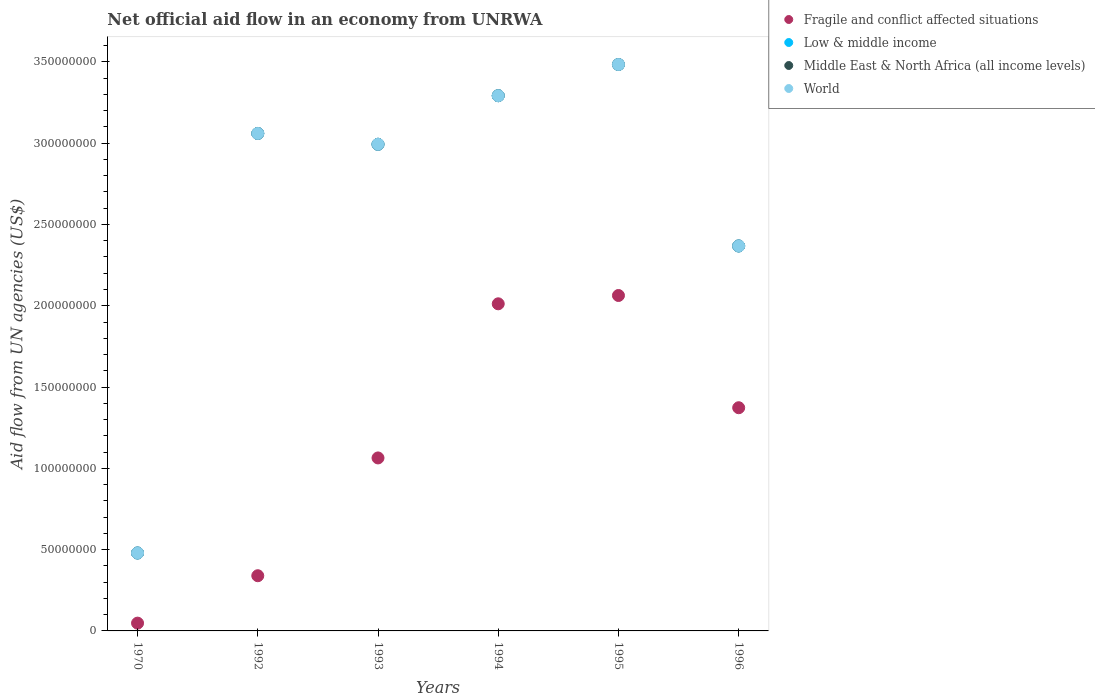What is the net official aid flow in Middle East & North Africa (all income levels) in 1993?
Provide a succinct answer. 2.99e+08. Across all years, what is the maximum net official aid flow in Low & middle income?
Your response must be concise. 3.48e+08. Across all years, what is the minimum net official aid flow in Low & middle income?
Offer a very short reply. 4.79e+07. In which year was the net official aid flow in Middle East & North Africa (all income levels) maximum?
Make the answer very short. 1995. In which year was the net official aid flow in World minimum?
Give a very brief answer. 1970. What is the total net official aid flow in Fragile and conflict affected situations in the graph?
Make the answer very short. 6.90e+08. What is the difference between the net official aid flow in Low & middle income in 1993 and that in 1994?
Provide a succinct answer. -2.99e+07. What is the difference between the net official aid flow in Low & middle income in 1970 and the net official aid flow in World in 1996?
Provide a succinct answer. -1.89e+08. What is the average net official aid flow in Fragile and conflict affected situations per year?
Keep it short and to the point. 1.15e+08. In the year 1993, what is the difference between the net official aid flow in Fragile and conflict affected situations and net official aid flow in Middle East & North Africa (all income levels)?
Your answer should be compact. -1.93e+08. What is the ratio of the net official aid flow in Fragile and conflict affected situations in 1970 to that in 1996?
Ensure brevity in your answer.  0.03. Is the difference between the net official aid flow in Fragile and conflict affected situations in 1970 and 1996 greater than the difference between the net official aid flow in Middle East & North Africa (all income levels) in 1970 and 1996?
Offer a terse response. Yes. What is the difference between the highest and the second highest net official aid flow in Low & middle income?
Keep it short and to the point. 1.92e+07. What is the difference between the highest and the lowest net official aid flow in Low & middle income?
Provide a succinct answer. 3.00e+08. Is the sum of the net official aid flow in Middle East & North Africa (all income levels) in 1970 and 1994 greater than the maximum net official aid flow in Fragile and conflict affected situations across all years?
Provide a succinct answer. Yes. Is it the case that in every year, the sum of the net official aid flow in Low & middle income and net official aid flow in Fragile and conflict affected situations  is greater than the sum of net official aid flow in World and net official aid flow in Middle East & North Africa (all income levels)?
Provide a succinct answer. No. Is it the case that in every year, the sum of the net official aid flow in Fragile and conflict affected situations and net official aid flow in Low & middle income  is greater than the net official aid flow in Middle East & North Africa (all income levels)?
Give a very brief answer. Yes. Is the net official aid flow in World strictly greater than the net official aid flow in Fragile and conflict affected situations over the years?
Provide a short and direct response. Yes. Is the net official aid flow in World strictly less than the net official aid flow in Low & middle income over the years?
Offer a terse response. No. How many years are there in the graph?
Keep it short and to the point. 6. What is the difference between two consecutive major ticks on the Y-axis?
Give a very brief answer. 5.00e+07. Does the graph contain any zero values?
Keep it short and to the point. No. How many legend labels are there?
Keep it short and to the point. 4. What is the title of the graph?
Offer a very short reply. Net official aid flow in an economy from UNRWA. What is the label or title of the X-axis?
Keep it short and to the point. Years. What is the label or title of the Y-axis?
Offer a very short reply. Aid flow from UN agencies (US$). What is the Aid flow from UN agencies (US$) in Fragile and conflict affected situations in 1970?
Provide a short and direct response. 4.79e+06. What is the Aid flow from UN agencies (US$) in Low & middle income in 1970?
Your answer should be compact. 4.79e+07. What is the Aid flow from UN agencies (US$) of Middle East & North Africa (all income levels) in 1970?
Give a very brief answer. 4.79e+07. What is the Aid flow from UN agencies (US$) in World in 1970?
Make the answer very short. 4.79e+07. What is the Aid flow from UN agencies (US$) in Fragile and conflict affected situations in 1992?
Provide a succinct answer. 3.40e+07. What is the Aid flow from UN agencies (US$) of Low & middle income in 1992?
Make the answer very short. 3.06e+08. What is the Aid flow from UN agencies (US$) of Middle East & North Africa (all income levels) in 1992?
Provide a short and direct response. 3.06e+08. What is the Aid flow from UN agencies (US$) in World in 1992?
Make the answer very short. 3.06e+08. What is the Aid flow from UN agencies (US$) of Fragile and conflict affected situations in 1993?
Provide a short and direct response. 1.06e+08. What is the Aid flow from UN agencies (US$) in Low & middle income in 1993?
Offer a terse response. 2.99e+08. What is the Aid flow from UN agencies (US$) in Middle East & North Africa (all income levels) in 1993?
Your answer should be compact. 2.99e+08. What is the Aid flow from UN agencies (US$) in World in 1993?
Keep it short and to the point. 2.99e+08. What is the Aid flow from UN agencies (US$) of Fragile and conflict affected situations in 1994?
Make the answer very short. 2.01e+08. What is the Aid flow from UN agencies (US$) in Low & middle income in 1994?
Ensure brevity in your answer.  3.29e+08. What is the Aid flow from UN agencies (US$) of Middle East & North Africa (all income levels) in 1994?
Keep it short and to the point. 3.29e+08. What is the Aid flow from UN agencies (US$) of World in 1994?
Offer a terse response. 3.29e+08. What is the Aid flow from UN agencies (US$) of Fragile and conflict affected situations in 1995?
Provide a succinct answer. 2.06e+08. What is the Aid flow from UN agencies (US$) of Low & middle income in 1995?
Give a very brief answer. 3.48e+08. What is the Aid flow from UN agencies (US$) of Middle East & North Africa (all income levels) in 1995?
Ensure brevity in your answer.  3.48e+08. What is the Aid flow from UN agencies (US$) in World in 1995?
Make the answer very short. 3.48e+08. What is the Aid flow from UN agencies (US$) in Fragile and conflict affected situations in 1996?
Keep it short and to the point. 1.37e+08. What is the Aid flow from UN agencies (US$) of Low & middle income in 1996?
Ensure brevity in your answer.  2.37e+08. What is the Aid flow from UN agencies (US$) of Middle East & North Africa (all income levels) in 1996?
Provide a succinct answer. 2.37e+08. What is the Aid flow from UN agencies (US$) of World in 1996?
Offer a very short reply. 2.37e+08. Across all years, what is the maximum Aid flow from UN agencies (US$) in Fragile and conflict affected situations?
Your response must be concise. 2.06e+08. Across all years, what is the maximum Aid flow from UN agencies (US$) of Low & middle income?
Your answer should be very brief. 3.48e+08. Across all years, what is the maximum Aid flow from UN agencies (US$) in Middle East & North Africa (all income levels)?
Your response must be concise. 3.48e+08. Across all years, what is the maximum Aid flow from UN agencies (US$) of World?
Provide a succinct answer. 3.48e+08. Across all years, what is the minimum Aid flow from UN agencies (US$) in Fragile and conflict affected situations?
Provide a short and direct response. 4.79e+06. Across all years, what is the minimum Aid flow from UN agencies (US$) in Low & middle income?
Make the answer very short. 4.79e+07. Across all years, what is the minimum Aid flow from UN agencies (US$) in Middle East & North Africa (all income levels)?
Offer a very short reply. 4.79e+07. Across all years, what is the minimum Aid flow from UN agencies (US$) in World?
Your answer should be compact. 4.79e+07. What is the total Aid flow from UN agencies (US$) of Fragile and conflict affected situations in the graph?
Provide a short and direct response. 6.90e+08. What is the total Aid flow from UN agencies (US$) of Low & middle income in the graph?
Offer a very short reply. 1.57e+09. What is the total Aid flow from UN agencies (US$) of Middle East & North Africa (all income levels) in the graph?
Give a very brief answer. 1.57e+09. What is the total Aid flow from UN agencies (US$) of World in the graph?
Offer a terse response. 1.57e+09. What is the difference between the Aid flow from UN agencies (US$) in Fragile and conflict affected situations in 1970 and that in 1992?
Your answer should be very brief. -2.92e+07. What is the difference between the Aid flow from UN agencies (US$) in Low & middle income in 1970 and that in 1992?
Make the answer very short. -2.58e+08. What is the difference between the Aid flow from UN agencies (US$) in Middle East & North Africa (all income levels) in 1970 and that in 1992?
Provide a succinct answer. -2.58e+08. What is the difference between the Aid flow from UN agencies (US$) in World in 1970 and that in 1992?
Give a very brief answer. -2.58e+08. What is the difference between the Aid flow from UN agencies (US$) in Fragile and conflict affected situations in 1970 and that in 1993?
Your response must be concise. -1.02e+08. What is the difference between the Aid flow from UN agencies (US$) of Low & middle income in 1970 and that in 1993?
Ensure brevity in your answer.  -2.51e+08. What is the difference between the Aid flow from UN agencies (US$) of Middle East & North Africa (all income levels) in 1970 and that in 1993?
Ensure brevity in your answer.  -2.51e+08. What is the difference between the Aid flow from UN agencies (US$) in World in 1970 and that in 1993?
Make the answer very short. -2.51e+08. What is the difference between the Aid flow from UN agencies (US$) of Fragile and conflict affected situations in 1970 and that in 1994?
Give a very brief answer. -1.96e+08. What is the difference between the Aid flow from UN agencies (US$) in Low & middle income in 1970 and that in 1994?
Keep it short and to the point. -2.81e+08. What is the difference between the Aid flow from UN agencies (US$) in Middle East & North Africa (all income levels) in 1970 and that in 1994?
Ensure brevity in your answer.  -2.81e+08. What is the difference between the Aid flow from UN agencies (US$) in World in 1970 and that in 1994?
Give a very brief answer. -2.81e+08. What is the difference between the Aid flow from UN agencies (US$) in Fragile and conflict affected situations in 1970 and that in 1995?
Provide a short and direct response. -2.02e+08. What is the difference between the Aid flow from UN agencies (US$) of Low & middle income in 1970 and that in 1995?
Provide a short and direct response. -3.00e+08. What is the difference between the Aid flow from UN agencies (US$) in Middle East & North Africa (all income levels) in 1970 and that in 1995?
Give a very brief answer. -3.00e+08. What is the difference between the Aid flow from UN agencies (US$) in World in 1970 and that in 1995?
Give a very brief answer. -3.00e+08. What is the difference between the Aid flow from UN agencies (US$) of Fragile and conflict affected situations in 1970 and that in 1996?
Keep it short and to the point. -1.32e+08. What is the difference between the Aid flow from UN agencies (US$) in Low & middle income in 1970 and that in 1996?
Offer a very short reply. -1.89e+08. What is the difference between the Aid flow from UN agencies (US$) of Middle East & North Africa (all income levels) in 1970 and that in 1996?
Your answer should be very brief. -1.89e+08. What is the difference between the Aid flow from UN agencies (US$) of World in 1970 and that in 1996?
Your answer should be compact. -1.89e+08. What is the difference between the Aid flow from UN agencies (US$) in Fragile and conflict affected situations in 1992 and that in 1993?
Give a very brief answer. -7.24e+07. What is the difference between the Aid flow from UN agencies (US$) of Low & middle income in 1992 and that in 1993?
Your answer should be compact. 6.65e+06. What is the difference between the Aid flow from UN agencies (US$) of Middle East & North Africa (all income levels) in 1992 and that in 1993?
Offer a terse response. 6.65e+06. What is the difference between the Aid flow from UN agencies (US$) of World in 1992 and that in 1993?
Your answer should be very brief. 6.65e+06. What is the difference between the Aid flow from UN agencies (US$) of Fragile and conflict affected situations in 1992 and that in 1994?
Provide a succinct answer. -1.67e+08. What is the difference between the Aid flow from UN agencies (US$) of Low & middle income in 1992 and that in 1994?
Your response must be concise. -2.32e+07. What is the difference between the Aid flow from UN agencies (US$) of Middle East & North Africa (all income levels) in 1992 and that in 1994?
Your response must be concise. -2.32e+07. What is the difference between the Aid flow from UN agencies (US$) of World in 1992 and that in 1994?
Offer a very short reply. -2.32e+07. What is the difference between the Aid flow from UN agencies (US$) of Fragile and conflict affected situations in 1992 and that in 1995?
Keep it short and to the point. -1.72e+08. What is the difference between the Aid flow from UN agencies (US$) of Low & middle income in 1992 and that in 1995?
Offer a terse response. -4.24e+07. What is the difference between the Aid flow from UN agencies (US$) in Middle East & North Africa (all income levels) in 1992 and that in 1995?
Your answer should be compact. -4.24e+07. What is the difference between the Aid flow from UN agencies (US$) of World in 1992 and that in 1995?
Make the answer very short. -4.24e+07. What is the difference between the Aid flow from UN agencies (US$) of Fragile and conflict affected situations in 1992 and that in 1996?
Offer a very short reply. -1.03e+08. What is the difference between the Aid flow from UN agencies (US$) of Low & middle income in 1992 and that in 1996?
Provide a short and direct response. 6.92e+07. What is the difference between the Aid flow from UN agencies (US$) in Middle East & North Africa (all income levels) in 1992 and that in 1996?
Provide a succinct answer. 6.92e+07. What is the difference between the Aid flow from UN agencies (US$) of World in 1992 and that in 1996?
Your answer should be compact. 6.92e+07. What is the difference between the Aid flow from UN agencies (US$) of Fragile and conflict affected situations in 1993 and that in 1994?
Offer a very short reply. -9.48e+07. What is the difference between the Aid flow from UN agencies (US$) of Low & middle income in 1993 and that in 1994?
Your answer should be very brief. -2.99e+07. What is the difference between the Aid flow from UN agencies (US$) in Middle East & North Africa (all income levels) in 1993 and that in 1994?
Your response must be concise. -2.99e+07. What is the difference between the Aid flow from UN agencies (US$) of World in 1993 and that in 1994?
Make the answer very short. -2.99e+07. What is the difference between the Aid flow from UN agencies (US$) of Fragile and conflict affected situations in 1993 and that in 1995?
Provide a short and direct response. -9.99e+07. What is the difference between the Aid flow from UN agencies (US$) in Low & middle income in 1993 and that in 1995?
Offer a very short reply. -4.91e+07. What is the difference between the Aid flow from UN agencies (US$) of Middle East & North Africa (all income levels) in 1993 and that in 1995?
Offer a very short reply. -4.91e+07. What is the difference between the Aid flow from UN agencies (US$) of World in 1993 and that in 1995?
Provide a succinct answer. -4.91e+07. What is the difference between the Aid flow from UN agencies (US$) of Fragile and conflict affected situations in 1993 and that in 1996?
Offer a very short reply. -3.09e+07. What is the difference between the Aid flow from UN agencies (US$) of Low & middle income in 1993 and that in 1996?
Your answer should be compact. 6.26e+07. What is the difference between the Aid flow from UN agencies (US$) of Middle East & North Africa (all income levels) in 1993 and that in 1996?
Make the answer very short. 6.26e+07. What is the difference between the Aid flow from UN agencies (US$) of World in 1993 and that in 1996?
Provide a short and direct response. 6.26e+07. What is the difference between the Aid flow from UN agencies (US$) in Fragile and conflict affected situations in 1994 and that in 1995?
Provide a succinct answer. -5.11e+06. What is the difference between the Aid flow from UN agencies (US$) of Low & middle income in 1994 and that in 1995?
Offer a terse response. -1.92e+07. What is the difference between the Aid flow from UN agencies (US$) of Middle East & North Africa (all income levels) in 1994 and that in 1995?
Offer a terse response. -1.92e+07. What is the difference between the Aid flow from UN agencies (US$) in World in 1994 and that in 1995?
Offer a very short reply. -1.92e+07. What is the difference between the Aid flow from UN agencies (US$) of Fragile and conflict affected situations in 1994 and that in 1996?
Give a very brief answer. 6.39e+07. What is the difference between the Aid flow from UN agencies (US$) of Low & middle income in 1994 and that in 1996?
Give a very brief answer. 9.24e+07. What is the difference between the Aid flow from UN agencies (US$) in Middle East & North Africa (all income levels) in 1994 and that in 1996?
Make the answer very short. 9.24e+07. What is the difference between the Aid flow from UN agencies (US$) in World in 1994 and that in 1996?
Provide a succinct answer. 9.24e+07. What is the difference between the Aid flow from UN agencies (US$) in Fragile and conflict affected situations in 1995 and that in 1996?
Give a very brief answer. 6.90e+07. What is the difference between the Aid flow from UN agencies (US$) in Low & middle income in 1995 and that in 1996?
Provide a succinct answer. 1.12e+08. What is the difference between the Aid flow from UN agencies (US$) of Middle East & North Africa (all income levels) in 1995 and that in 1996?
Ensure brevity in your answer.  1.12e+08. What is the difference between the Aid flow from UN agencies (US$) in World in 1995 and that in 1996?
Offer a terse response. 1.12e+08. What is the difference between the Aid flow from UN agencies (US$) of Fragile and conflict affected situations in 1970 and the Aid flow from UN agencies (US$) of Low & middle income in 1992?
Make the answer very short. -3.01e+08. What is the difference between the Aid flow from UN agencies (US$) of Fragile and conflict affected situations in 1970 and the Aid flow from UN agencies (US$) of Middle East & North Africa (all income levels) in 1992?
Provide a succinct answer. -3.01e+08. What is the difference between the Aid flow from UN agencies (US$) in Fragile and conflict affected situations in 1970 and the Aid flow from UN agencies (US$) in World in 1992?
Offer a terse response. -3.01e+08. What is the difference between the Aid flow from UN agencies (US$) in Low & middle income in 1970 and the Aid flow from UN agencies (US$) in Middle East & North Africa (all income levels) in 1992?
Your response must be concise. -2.58e+08. What is the difference between the Aid flow from UN agencies (US$) of Low & middle income in 1970 and the Aid flow from UN agencies (US$) of World in 1992?
Give a very brief answer. -2.58e+08. What is the difference between the Aid flow from UN agencies (US$) in Middle East & North Africa (all income levels) in 1970 and the Aid flow from UN agencies (US$) in World in 1992?
Keep it short and to the point. -2.58e+08. What is the difference between the Aid flow from UN agencies (US$) in Fragile and conflict affected situations in 1970 and the Aid flow from UN agencies (US$) in Low & middle income in 1993?
Give a very brief answer. -2.95e+08. What is the difference between the Aid flow from UN agencies (US$) of Fragile and conflict affected situations in 1970 and the Aid flow from UN agencies (US$) of Middle East & North Africa (all income levels) in 1993?
Offer a terse response. -2.95e+08. What is the difference between the Aid flow from UN agencies (US$) in Fragile and conflict affected situations in 1970 and the Aid flow from UN agencies (US$) in World in 1993?
Your answer should be compact. -2.95e+08. What is the difference between the Aid flow from UN agencies (US$) in Low & middle income in 1970 and the Aid flow from UN agencies (US$) in Middle East & North Africa (all income levels) in 1993?
Your response must be concise. -2.51e+08. What is the difference between the Aid flow from UN agencies (US$) in Low & middle income in 1970 and the Aid flow from UN agencies (US$) in World in 1993?
Offer a terse response. -2.51e+08. What is the difference between the Aid flow from UN agencies (US$) of Middle East & North Africa (all income levels) in 1970 and the Aid flow from UN agencies (US$) of World in 1993?
Your response must be concise. -2.51e+08. What is the difference between the Aid flow from UN agencies (US$) in Fragile and conflict affected situations in 1970 and the Aid flow from UN agencies (US$) in Low & middle income in 1994?
Keep it short and to the point. -3.24e+08. What is the difference between the Aid flow from UN agencies (US$) of Fragile and conflict affected situations in 1970 and the Aid flow from UN agencies (US$) of Middle East & North Africa (all income levels) in 1994?
Offer a very short reply. -3.24e+08. What is the difference between the Aid flow from UN agencies (US$) in Fragile and conflict affected situations in 1970 and the Aid flow from UN agencies (US$) in World in 1994?
Keep it short and to the point. -3.24e+08. What is the difference between the Aid flow from UN agencies (US$) of Low & middle income in 1970 and the Aid flow from UN agencies (US$) of Middle East & North Africa (all income levels) in 1994?
Your answer should be very brief. -2.81e+08. What is the difference between the Aid flow from UN agencies (US$) of Low & middle income in 1970 and the Aid flow from UN agencies (US$) of World in 1994?
Your answer should be very brief. -2.81e+08. What is the difference between the Aid flow from UN agencies (US$) of Middle East & North Africa (all income levels) in 1970 and the Aid flow from UN agencies (US$) of World in 1994?
Make the answer very short. -2.81e+08. What is the difference between the Aid flow from UN agencies (US$) of Fragile and conflict affected situations in 1970 and the Aid flow from UN agencies (US$) of Low & middle income in 1995?
Provide a succinct answer. -3.44e+08. What is the difference between the Aid flow from UN agencies (US$) in Fragile and conflict affected situations in 1970 and the Aid flow from UN agencies (US$) in Middle East & North Africa (all income levels) in 1995?
Offer a very short reply. -3.44e+08. What is the difference between the Aid flow from UN agencies (US$) of Fragile and conflict affected situations in 1970 and the Aid flow from UN agencies (US$) of World in 1995?
Offer a terse response. -3.44e+08. What is the difference between the Aid flow from UN agencies (US$) of Low & middle income in 1970 and the Aid flow from UN agencies (US$) of Middle East & North Africa (all income levels) in 1995?
Your answer should be very brief. -3.00e+08. What is the difference between the Aid flow from UN agencies (US$) in Low & middle income in 1970 and the Aid flow from UN agencies (US$) in World in 1995?
Your answer should be compact. -3.00e+08. What is the difference between the Aid flow from UN agencies (US$) of Middle East & North Africa (all income levels) in 1970 and the Aid flow from UN agencies (US$) of World in 1995?
Ensure brevity in your answer.  -3.00e+08. What is the difference between the Aid flow from UN agencies (US$) of Fragile and conflict affected situations in 1970 and the Aid flow from UN agencies (US$) of Low & middle income in 1996?
Offer a terse response. -2.32e+08. What is the difference between the Aid flow from UN agencies (US$) in Fragile and conflict affected situations in 1970 and the Aid flow from UN agencies (US$) in Middle East & North Africa (all income levels) in 1996?
Your answer should be very brief. -2.32e+08. What is the difference between the Aid flow from UN agencies (US$) of Fragile and conflict affected situations in 1970 and the Aid flow from UN agencies (US$) of World in 1996?
Provide a short and direct response. -2.32e+08. What is the difference between the Aid flow from UN agencies (US$) in Low & middle income in 1970 and the Aid flow from UN agencies (US$) in Middle East & North Africa (all income levels) in 1996?
Offer a terse response. -1.89e+08. What is the difference between the Aid flow from UN agencies (US$) in Low & middle income in 1970 and the Aid flow from UN agencies (US$) in World in 1996?
Provide a short and direct response. -1.89e+08. What is the difference between the Aid flow from UN agencies (US$) of Middle East & North Africa (all income levels) in 1970 and the Aid flow from UN agencies (US$) of World in 1996?
Provide a succinct answer. -1.89e+08. What is the difference between the Aid flow from UN agencies (US$) in Fragile and conflict affected situations in 1992 and the Aid flow from UN agencies (US$) in Low & middle income in 1993?
Your response must be concise. -2.65e+08. What is the difference between the Aid flow from UN agencies (US$) in Fragile and conflict affected situations in 1992 and the Aid flow from UN agencies (US$) in Middle East & North Africa (all income levels) in 1993?
Keep it short and to the point. -2.65e+08. What is the difference between the Aid flow from UN agencies (US$) in Fragile and conflict affected situations in 1992 and the Aid flow from UN agencies (US$) in World in 1993?
Give a very brief answer. -2.65e+08. What is the difference between the Aid flow from UN agencies (US$) in Low & middle income in 1992 and the Aid flow from UN agencies (US$) in Middle East & North Africa (all income levels) in 1993?
Ensure brevity in your answer.  6.65e+06. What is the difference between the Aid flow from UN agencies (US$) of Low & middle income in 1992 and the Aid flow from UN agencies (US$) of World in 1993?
Your answer should be very brief. 6.65e+06. What is the difference between the Aid flow from UN agencies (US$) in Middle East & North Africa (all income levels) in 1992 and the Aid flow from UN agencies (US$) in World in 1993?
Provide a short and direct response. 6.65e+06. What is the difference between the Aid flow from UN agencies (US$) in Fragile and conflict affected situations in 1992 and the Aid flow from UN agencies (US$) in Low & middle income in 1994?
Keep it short and to the point. -2.95e+08. What is the difference between the Aid flow from UN agencies (US$) in Fragile and conflict affected situations in 1992 and the Aid flow from UN agencies (US$) in Middle East & North Africa (all income levels) in 1994?
Offer a very short reply. -2.95e+08. What is the difference between the Aid flow from UN agencies (US$) in Fragile and conflict affected situations in 1992 and the Aid flow from UN agencies (US$) in World in 1994?
Offer a very short reply. -2.95e+08. What is the difference between the Aid flow from UN agencies (US$) of Low & middle income in 1992 and the Aid flow from UN agencies (US$) of Middle East & North Africa (all income levels) in 1994?
Provide a succinct answer. -2.32e+07. What is the difference between the Aid flow from UN agencies (US$) of Low & middle income in 1992 and the Aid flow from UN agencies (US$) of World in 1994?
Offer a very short reply. -2.32e+07. What is the difference between the Aid flow from UN agencies (US$) of Middle East & North Africa (all income levels) in 1992 and the Aid flow from UN agencies (US$) of World in 1994?
Provide a short and direct response. -2.32e+07. What is the difference between the Aid flow from UN agencies (US$) in Fragile and conflict affected situations in 1992 and the Aid flow from UN agencies (US$) in Low & middle income in 1995?
Make the answer very short. -3.14e+08. What is the difference between the Aid flow from UN agencies (US$) in Fragile and conflict affected situations in 1992 and the Aid flow from UN agencies (US$) in Middle East & North Africa (all income levels) in 1995?
Ensure brevity in your answer.  -3.14e+08. What is the difference between the Aid flow from UN agencies (US$) in Fragile and conflict affected situations in 1992 and the Aid flow from UN agencies (US$) in World in 1995?
Provide a short and direct response. -3.14e+08. What is the difference between the Aid flow from UN agencies (US$) of Low & middle income in 1992 and the Aid flow from UN agencies (US$) of Middle East & North Africa (all income levels) in 1995?
Your answer should be compact. -4.24e+07. What is the difference between the Aid flow from UN agencies (US$) of Low & middle income in 1992 and the Aid flow from UN agencies (US$) of World in 1995?
Your response must be concise. -4.24e+07. What is the difference between the Aid flow from UN agencies (US$) in Middle East & North Africa (all income levels) in 1992 and the Aid flow from UN agencies (US$) in World in 1995?
Make the answer very short. -4.24e+07. What is the difference between the Aid flow from UN agencies (US$) in Fragile and conflict affected situations in 1992 and the Aid flow from UN agencies (US$) in Low & middle income in 1996?
Offer a very short reply. -2.03e+08. What is the difference between the Aid flow from UN agencies (US$) of Fragile and conflict affected situations in 1992 and the Aid flow from UN agencies (US$) of Middle East & North Africa (all income levels) in 1996?
Your answer should be very brief. -2.03e+08. What is the difference between the Aid flow from UN agencies (US$) of Fragile and conflict affected situations in 1992 and the Aid flow from UN agencies (US$) of World in 1996?
Offer a terse response. -2.03e+08. What is the difference between the Aid flow from UN agencies (US$) in Low & middle income in 1992 and the Aid flow from UN agencies (US$) in Middle East & North Africa (all income levels) in 1996?
Offer a terse response. 6.92e+07. What is the difference between the Aid flow from UN agencies (US$) of Low & middle income in 1992 and the Aid flow from UN agencies (US$) of World in 1996?
Offer a terse response. 6.92e+07. What is the difference between the Aid flow from UN agencies (US$) in Middle East & North Africa (all income levels) in 1992 and the Aid flow from UN agencies (US$) in World in 1996?
Ensure brevity in your answer.  6.92e+07. What is the difference between the Aid flow from UN agencies (US$) in Fragile and conflict affected situations in 1993 and the Aid flow from UN agencies (US$) in Low & middle income in 1994?
Offer a terse response. -2.23e+08. What is the difference between the Aid flow from UN agencies (US$) in Fragile and conflict affected situations in 1993 and the Aid flow from UN agencies (US$) in Middle East & North Africa (all income levels) in 1994?
Give a very brief answer. -2.23e+08. What is the difference between the Aid flow from UN agencies (US$) of Fragile and conflict affected situations in 1993 and the Aid flow from UN agencies (US$) of World in 1994?
Keep it short and to the point. -2.23e+08. What is the difference between the Aid flow from UN agencies (US$) in Low & middle income in 1993 and the Aid flow from UN agencies (US$) in Middle East & North Africa (all income levels) in 1994?
Your answer should be compact. -2.99e+07. What is the difference between the Aid flow from UN agencies (US$) in Low & middle income in 1993 and the Aid flow from UN agencies (US$) in World in 1994?
Ensure brevity in your answer.  -2.99e+07. What is the difference between the Aid flow from UN agencies (US$) in Middle East & North Africa (all income levels) in 1993 and the Aid flow from UN agencies (US$) in World in 1994?
Give a very brief answer. -2.99e+07. What is the difference between the Aid flow from UN agencies (US$) of Fragile and conflict affected situations in 1993 and the Aid flow from UN agencies (US$) of Low & middle income in 1995?
Your answer should be very brief. -2.42e+08. What is the difference between the Aid flow from UN agencies (US$) in Fragile and conflict affected situations in 1993 and the Aid flow from UN agencies (US$) in Middle East & North Africa (all income levels) in 1995?
Your answer should be compact. -2.42e+08. What is the difference between the Aid flow from UN agencies (US$) in Fragile and conflict affected situations in 1993 and the Aid flow from UN agencies (US$) in World in 1995?
Give a very brief answer. -2.42e+08. What is the difference between the Aid flow from UN agencies (US$) in Low & middle income in 1993 and the Aid flow from UN agencies (US$) in Middle East & North Africa (all income levels) in 1995?
Ensure brevity in your answer.  -4.91e+07. What is the difference between the Aid flow from UN agencies (US$) in Low & middle income in 1993 and the Aid flow from UN agencies (US$) in World in 1995?
Ensure brevity in your answer.  -4.91e+07. What is the difference between the Aid flow from UN agencies (US$) of Middle East & North Africa (all income levels) in 1993 and the Aid flow from UN agencies (US$) of World in 1995?
Provide a short and direct response. -4.91e+07. What is the difference between the Aid flow from UN agencies (US$) of Fragile and conflict affected situations in 1993 and the Aid flow from UN agencies (US$) of Low & middle income in 1996?
Your answer should be very brief. -1.30e+08. What is the difference between the Aid flow from UN agencies (US$) in Fragile and conflict affected situations in 1993 and the Aid flow from UN agencies (US$) in Middle East & North Africa (all income levels) in 1996?
Provide a short and direct response. -1.30e+08. What is the difference between the Aid flow from UN agencies (US$) of Fragile and conflict affected situations in 1993 and the Aid flow from UN agencies (US$) of World in 1996?
Provide a succinct answer. -1.30e+08. What is the difference between the Aid flow from UN agencies (US$) in Low & middle income in 1993 and the Aid flow from UN agencies (US$) in Middle East & North Africa (all income levels) in 1996?
Give a very brief answer. 6.26e+07. What is the difference between the Aid flow from UN agencies (US$) in Low & middle income in 1993 and the Aid flow from UN agencies (US$) in World in 1996?
Provide a short and direct response. 6.26e+07. What is the difference between the Aid flow from UN agencies (US$) in Middle East & North Africa (all income levels) in 1993 and the Aid flow from UN agencies (US$) in World in 1996?
Provide a short and direct response. 6.26e+07. What is the difference between the Aid flow from UN agencies (US$) of Fragile and conflict affected situations in 1994 and the Aid flow from UN agencies (US$) of Low & middle income in 1995?
Make the answer very short. -1.47e+08. What is the difference between the Aid flow from UN agencies (US$) of Fragile and conflict affected situations in 1994 and the Aid flow from UN agencies (US$) of Middle East & North Africa (all income levels) in 1995?
Keep it short and to the point. -1.47e+08. What is the difference between the Aid flow from UN agencies (US$) of Fragile and conflict affected situations in 1994 and the Aid flow from UN agencies (US$) of World in 1995?
Ensure brevity in your answer.  -1.47e+08. What is the difference between the Aid flow from UN agencies (US$) in Low & middle income in 1994 and the Aid flow from UN agencies (US$) in Middle East & North Africa (all income levels) in 1995?
Your answer should be very brief. -1.92e+07. What is the difference between the Aid flow from UN agencies (US$) in Low & middle income in 1994 and the Aid flow from UN agencies (US$) in World in 1995?
Your answer should be compact. -1.92e+07. What is the difference between the Aid flow from UN agencies (US$) of Middle East & North Africa (all income levels) in 1994 and the Aid flow from UN agencies (US$) of World in 1995?
Your answer should be very brief. -1.92e+07. What is the difference between the Aid flow from UN agencies (US$) of Fragile and conflict affected situations in 1994 and the Aid flow from UN agencies (US$) of Low & middle income in 1996?
Your response must be concise. -3.56e+07. What is the difference between the Aid flow from UN agencies (US$) of Fragile and conflict affected situations in 1994 and the Aid flow from UN agencies (US$) of Middle East & North Africa (all income levels) in 1996?
Provide a succinct answer. -3.56e+07. What is the difference between the Aid flow from UN agencies (US$) in Fragile and conflict affected situations in 1994 and the Aid flow from UN agencies (US$) in World in 1996?
Provide a short and direct response. -3.56e+07. What is the difference between the Aid flow from UN agencies (US$) in Low & middle income in 1994 and the Aid flow from UN agencies (US$) in Middle East & North Africa (all income levels) in 1996?
Offer a very short reply. 9.24e+07. What is the difference between the Aid flow from UN agencies (US$) in Low & middle income in 1994 and the Aid flow from UN agencies (US$) in World in 1996?
Your response must be concise. 9.24e+07. What is the difference between the Aid flow from UN agencies (US$) of Middle East & North Africa (all income levels) in 1994 and the Aid flow from UN agencies (US$) of World in 1996?
Ensure brevity in your answer.  9.24e+07. What is the difference between the Aid flow from UN agencies (US$) of Fragile and conflict affected situations in 1995 and the Aid flow from UN agencies (US$) of Low & middle income in 1996?
Give a very brief answer. -3.05e+07. What is the difference between the Aid flow from UN agencies (US$) of Fragile and conflict affected situations in 1995 and the Aid flow from UN agencies (US$) of Middle East & North Africa (all income levels) in 1996?
Your answer should be very brief. -3.05e+07. What is the difference between the Aid flow from UN agencies (US$) in Fragile and conflict affected situations in 1995 and the Aid flow from UN agencies (US$) in World in 1996?
Give a very brief answer. -3.05e+07. What is the difference between the Aid flow from UN agencies (US$) of Low & middle income in 1995 and the Aid flow from UN agencies (US$) of Middle East & North Africa (all income levels) in 1996?
Offer a very short reply. 1.12e+08. What is the difference between the Aid flow from UN agencies (US$) of Low & middle income in 1995 and the Aid flow from UN agencies (US$) of World in 1996?
Keep it short and to the point. 1.12e+08. What is the difference between the Aid flow from UN agencies (US$) of Middle East & North Africa (all income levels) in 1995 and the Aid flow from UN agencies (US$) of World in 1996?
Keep it short and to the point. 1.12e+08. What is the average Aid flow from UN agencies (US$) of Fragile and conflict affected situations per year?
Make the answer very short. 1.15e+08. What is the average Aid flow from UN agencies (US$) in Low & middle income per year?
Your answer should be very brief. 2.61e+08. What is the average Aid flow from UN agencies (US$) in Middle East & North Africa (all income levels) per year?
Your answer should be very brief. 2.61e+08. What is the average Aid flow from UN agencies (US$) of World per year?
Your response must be concise. 2.61e+08. In the year 1970, what is the difference between the Aid flow from UN agencies (US$) in Fragile and conflict affected situations and Aid flow from UN agencies (US$) in Low & middle income?
Provide a short and direct response. -4.31e+07. In the year 1970, what is the difference between the Aid flow from UN agencies (US$) in Fragile and conflict affected situations and Aid flow from UN agencies (US$) in Middle East & North Africa (all income levels)?
Your response must be concise. -4.31e+07. In the year 1970, what is the difference between the Aid flow from UN agencies (US$) of Fragile and conflict affected situations and Aid flow from UN agencies (US$) of World?
Your answer should be very brief. -4.31e+07. In the year 1970, what is the difference between the Aid flow from UN agencies (US$) in Low & middle income and Aid flow from UN agencies (US$) in World?
Provide a succinct answer. 0. In the year 1992, what is the difference between the Aid flow from UN agencies (US$) in Fragile and conflict affected situations and Aid flow from UN agencies (US$) in Low & middle income?
Ensure brevity in your answer.  -2.72e+08. In the year 1992, what is the difference between the Aid flow from UN agencies (US$) in Fragile and conflict affected situations and Aid flow from UN agencies (US$) in Middle East & North Africa (all income levels)?
Provide a succinct answer. -2.72e+08. In the year 1992, what is the difference between the Aid flow from UN agencies (US$) of Fragile and conflict affected situations and Aid flow from UN agencies (US$) of World?
Offer a terse response. -2.72e+08. In the year 1992, what is the difference between the Aid flow from UN agencies (US$) in Low & middle income and Aid flow from UN agencies (US$) in World?
Your answer should be compact. 0. In the year 1992, what is the difference between the Aid flow from UN agencies (US$) of Middle East & North Africa (all income levels) and Aid flow from UN agencies (US$) of World?
Give a very brief answer. 0. In the year 1993, what is the difference between the Aid flow from UN agencies (US$) of Fragile and conflict affected situations and Aid flow from UN agencies (US$) of Low & middle income?
Ensure brevity in your answer.  -1.93e+08. In the year 1993, what is the difference between the Aid flow from UN agencies (US$) in Fragile and conflict affected situations and Aid flow from UN agencies (US$) in Middle East & North Africa (all income levels)?
Keep it short and to the point. -1.93e+08. In the year 1993, what is the difference between the Aid flow from UN agencies (US$) in Fragile and conflict affected situations and Aid flow from UN agencies (US$) in World?
Keep it short and to the point. -1.93e+08. In the year 1993, what is the difference between the Aid flow from UN agencies (US$) in Low & middle income and Aid flow from UN agencies (US$) in Middle East & North Africa (all income levels)?
Keep it short and to the point. 0. In the year 1993, what is the difference between the Aid flow from UN agencies (US$) in Low & middle income and Aid flow from UN agencies (US$) in World?
Give a very brief answer. 0. In the year 1993, what is the difference between the Aid flow from UN agencies (US$) in Middle East & North Africa (all income levels) and Aid flow from UN agencies (US$) in World?
Offer a very short reply. 0. In the year 1994, what is the difference between the Aid flow from UN agencies (US$) in Fragile and conflict affected situations and Aid flow from UN agencies (US$) in Low & middle income?
Ensure brevity in your answer.  -1.28e+08. In the year 1994, what is the difference between the Aid flow from UN agencies (US$) in Fragile and conflict affected situations and Aid flow from UN agencies (US$) in Middle East & North Africa (all income levels)?
Make the answer very short. -1.28e+08. In the year 1994, what is the difference between the Aid flow from UN agencies (US$) in Fragile and conflict affected situations and Aid flow from UN agencies (US$) in World?
Give a very brief answer. -1.28e+08. In the year 1995, what is the difference between the Aid flow from UN agencies (US$) of Fragile and conflict affected situations and Aid flow from UN agencies (US$) of Low & middle income?
Make the answer very short. -1.42e+08. In the year 1995, what is the difference between the Aid flow from UN agencies (US$) of Fragile and conflict affected situations and Aid flow from UN agencies (US$) of Middle East & North Africa (all income levels)?
Make the answer very short. -1.42e+08. In the year 1995, what is the difference between the Aid flow from UN agencies (US$) of Fragile and conflict affected situations and Aid flow from UN agencies (US$) of World?
Provide a short and direct response. -1.42e+08. In the year 1995, what is the difference between the Aid flow from UN agencies (US$) of Low & middle income and Aid flow from UN agencies (US$) of Middle East & North Africa (all income levels)?
Your answer should be very brief. 0. In the year 1995, what is the difference between the Aid flow from UN agencies (US$) of Low & middle income and Aid flow from UN agencies (US$) of World?
Ensure brevity in your answer.  0. In the year 1996, what is the difference between the Aid flow from UN agencies (US$) of Fragile and conflict affected situations and Aid flow from UN agencies (US$) of Low & middle income?
Your answer should be compact. -9.95e+07. In the year 1996, what is the difference between the Aid flow from UN agencies (US$) in Fragile and conflict affected situations and Aid flow from UN agencies (US$) in Middle East & North Africa (all income levels)?
Your answer should be compact. -9.95e+07. In the year 1996, what is the difference between the Aid flow from UN agencies (US$) of Fragile and conflict affected situations and Aid flow from UN agencies (US$) of World?
Provide a short and direct response. -9.95e+07. In the year 1996, what is the difference between the Aid flow from UN agencies (US$) in Low & middle income and Aid flow from UN agencies (US$) in Middle East & North Africa (all income levels)?
Give a very brief answer. 0. What is the ratio of the Aid flow from UN agencies (US$) of Fragile and conflict affected situations in 1970 to that in 1992?
Provide a short and direct response. 0.14. What is the ratio of the Aid flow from UN agencies (US$) of Low & middle income in 1970 to that in 1992?
Offer a terse response. 0.16. What is the ratio of the Aid flow from UN agencies (US$) in Middle East & North Africa (all income levels) in 1970 to that in 1992?
Offer a very short reply. 0.16. What is the ratio of the Aid flow from UN agencies (US$) of World in 1970 to that in 1992?
Provide a succinct answer. 0.16. What is the ratio of the Aid flow from UN agencies (US$) in Fragile and conflict affected situations in 1970 to that in 1993?
Keep it short and to the point. 0.04. What is the ratio of the Aid flow from UN agencies (US$) in Low & middle income in 1970 to that in 1993?
Ensure brevity in your answer.  0.16. What is the ratio of the Aid flow from UN agencies (US$) in Middle East & North Africa (all income levels) in 1970 to that in 1993?
Offer a very short reply. 0.16. What is the ratio of the Aid flow from UN agencies (US$) in World in 1970 to that in 1993?
Ensure brevity in your answer.  0.16. What is the ratio of the Aid flow from UN agencies (US$) in Fragile and conflict affected situations in 1970 to that in 1994?
Ensure brevity in your answer.  0.02. What is the ratio of the Aid flow from UN agencies (US$) of Low & middle income in 1970 to that in 1994?
Ensure brevity in your answer.  0.15. What is the ratio of the Aid flow from UN agencies (US$) of Middle East & North Africa (all income levels) in 1970 to that in 1994?
Offer a terse response. 0.15. What is the ratio of the Aid flow from UN agencies (US$) of World in 1970 to that in 1994?
Keep it short and to the point. 0.15. What is the ratio of the Aid flow from UN agencies (US$) of Fragile and conflict affected situations in 1970 to that in 1995?
Provide a short and direct response. 0.02. What is the ratio of the Aid flow from UN agencies (US$) of Low & middle income in 1970 to that in 1995?
Offer a very short reply. 0.14. What is the ratio of the Aid flow from UN agencies (US$) in Middle East & North Africa (all income levels) in 1970 to that in 1995?
Give a very brief answer. 0.14. What is the ratio of the Aid flow from UN agencies (US$) of World in 1970 to that in 1995?
Offer a very short reply. 0.14. What is the ratio of the Aid flow from UN agencies (US$) in Fragile and conflict affected situations in 1970 to that in 1996?
Provide a succinct answer. 0.03. What is the ratio of the Aid flow from UN agencies (US$) of Low & middle income in 1970 to that in 1996?
Give a very brief answer. 0.2. What is the ratio of the Aid flow from UN agencies (US$) in Middle East & North Africa (all income levels) in 1970 to that in 1996?
Your answer should be very brief. 0.2. What is the ratio of the Aid flow from UN agencies (US$) in World in 1970 to that in 1996?
Make the answer very short. 0.2. What is the ratio of the Aid flow from UN agencies (US$) of Fragile and conflict affected situations in 1992 to that in 1993?
Keep it short and to the point. 0.32. What is the ratio of the Aid flow from UN agencies (US$) of Low & middle income in 1992 to that in 1993?
Offer a terse response. 1.02. What is the ratio of the Aid flow from UN agencies (US$) of Middle East & North Africa (all income levels) in 1992 to that in 1993?
Keep it short and to the point. 1.02. What is the ratio of the Aid flow from UN agencies (US$) in World in 1992 to that in 1993?
Provide a short and direct response. 1.02. What is the ratio of the Aid flow from UN agencies (US$) of Fragile and conflict affected situations in 1992 to that in 1994?
Your answer should be very brief. 0.17. What is the ratio of the Aid flow from UN agencies (US$) in Low & middle income in 1992 to that in 1994?
Keep it short and to the point. 0.93. What is the ratio of the Aid flow from UN agencies (US$) in Middle East & North Africa (all income levels) in 1992 to that in 1994?
Make the answer very short. 0.93. What is the ratio of the Aid flow from UN agencies (US$) of World in 1992 to that in 1994?
Offer a terse response. 0.93. What is the ratio of the Aid flow from UN agencies (US$) in Fragile and conflict affected situations in 1992 to that in 1995?
Give a very brief answer. 0.16. What is the ratio of the Aid flow from UN agencies (US$) in Low & middle income in 1992 to that in 1995?
Ensure brevity in your answer.  0.88. What is the ratio of the Aid flow from UN agencies (US$) of Middle East & North Africa (all income levels) in 1992 to that in 1995?
Provide a succinct answer. 0.88. What is the ratio of the Aid flow from UN agencies (US$) in World in 1992 to that in 1995?
Your answer should be very brief. 0.88. What is the ratio of the Aid flow from UN agencies (US$) of Fragile and conflict affected situations in 1992 to that in 1996?
Your answer should be very brief. 0.25. What is the ratio of the Aid flow from UN agencies (US$) of Low & middle income in 1992 to that in 1996?
Keep it short and to the point. 1.29. What is the ratio of the Aid flow from UN agencies (US$) of Middle East & North Africa (all income levels) in 1992 to that in 1996?
Your answer should be compact. 1.29. What is the ratio of the Aid flow from UN agencies (US$) of World in 1992 to that in 1996?
Your answer should be very brief. 1.29. What is the ratio of the Aid flow from UN agencies (US$) in Fragile and conflict affected situations in 1993 to that in 1994?
Keep it short and to the point. 0.53. What is the ratio of the Aid flow from UN agencies (US$) in Low & middle income in 1993 to that in 1994?
Provide a succinct answer. 0.91. What is the ratio of the Aid flow from UN agencies (US$) in Middle East & North Africa (all income levels) in 1993 to that in 1994?
Your answer should be compact. 0.91. What is the ratio of the Aid flow from UN agencies (US$) of World in 1993 to that in 1994?
Ensure brevity in your answer.  0.91. What is the ratio of the Aid flow from UN agencies (US$) of Fragile and conflict affected situations in 1993 to that in 1995?
Your response must be concise. 0.52. What is the ratio of the Aid flow from UN agencies (US$) in Low & middle income in 1993 to that in 1995?
Give a very brief answer. 0.86. What is the ratio of the Aid flow from UN agencies (US$) in Middle East & North Africa (all income levels) in 1993 to that in 1995?
Ensure brevity in your answer.  0.86. What is the ratio of the Aid flow from UN agencies (US$) of World in 1993 to that in 1995?
Provide a succinct answer. 0.86. What is the ratio of the Aid flow from UN agencies (US$) in Fragile and conflict affected situations in 1993 to that in 1996?
Ensure brevity in your answer.  0.78. What is the ratio of the Aid flow from UN agencies (US$) in Low & middle income in 1993 to that in 1996?
Give a very brief answer. 1.26. What is the ratio of the Aid flow from UN agencies (US$) of Middle East & North Africa (all income levels) in 1993 to that in 1996?
Your response must be concise. 1.26. What is the ratio of the Aid flow from UN agencies (US$) in World in 1993 to that in 1996?
Give a very brief answer. 1.26. What is the ratio of the Aid flow from UN agencies (US$) of Fragile and conflict affected situations in 1994 to that in 1995?
Make the answer very short. 0.98. What is the ratio of the Aid flow from UN agencies (US$) in Low & middle income in 1994 to that in 1995?
Give a very brief answer. 0.94. What is the ratio of the Aid flow from UN agencies (US$) in Middle East & North Africa (all income levels) in 1994 to that in 1995?
Provide a short and direct response. 0.94. What is the ratio of the Aid flow from UN agencies (US$) in World in 1994 to that in 1995?
Your answer should be compact. 0.94. What is the ratio of the Aid flow from UN agencies (US$) in Fragile and conflict affected situations in 1994 to that in 1996?
Your response must be concise. 1.47. What is the ratio of the Aid flow from UN agencies (US$) in Low & middle income in 1994 to that in 1996?
Give a very brief answer. 1.39. What is the ratio of the Aid flow from UN agencies (US$) in Middle East & North Africa (all income levels) in 1994 to that in 1996?
Your answer should be very brief. 1.39. What is the ratio of the Aid flow from UN agencies (US$) in World in 1994 to that in 1996?
Make the answer very short. 1.39. What is the ratio of the Aid flow from UN agencies (US$) in Fragile and conflict affected situations in 1995 to that in 1996?
Make the answer very short. 1.5. What is the ratio of the Aid flow from UN agencies (US$) of Low & middle income in 1995 to that in 1996?
Your response must be concise. 1.47. What is the ratio of the Aid flow from UN agencies (US$) of Middle East & North Africa (all income levels) in 1995 to that in 1996?
Your response must be concise. 1.47. What is the ratio of the Aid flow from UN agencies (US$) of World in 1995 to that in 1996?
Make the answer very short. 1.47. What is the difference between the highest and the second highest Aid flow from UN agencies (US$) of Fragile and conflict affected situations?
Give a very brief answer. 5.11e+06. What is the difference between the highest and the second highest Aid flow from UN agencies (US$) of Low & middle income?
Your answer should be very brief. 1.92e+07. What is the difference between the highest and the second highest Aid flow from UN agencies (US$) of Middle East & North Africa (all income levels)?
Your answer should be compact. 1.92e+07. What is the difference between the highest and the second highest Aid flow from UN agencies (US$) in World?
Ensure brevity in your answer.  1.92e+07. What is the difference between the highest and the lowest Aid flow from UN agencies (US$) of Fragile and conflict affected situations?
Your answer should be compact. 2.02e+08. What is the difference between the highest and the lowest Aid flow from UN agencies (US$) of Low & middle income?
Provide a short and direct response. 3.00e+08. What is the difference between the highest and the lowest Aid flow from UN agencies (US$) in Middle East & North Africa (all income levels)?
Your answer should be very brief. 3.00e+08. What is the difference between the highest and the lowest Aid flow from UN agencies (US$) of World?
Provide a short and direct response. 3.00e+08. 